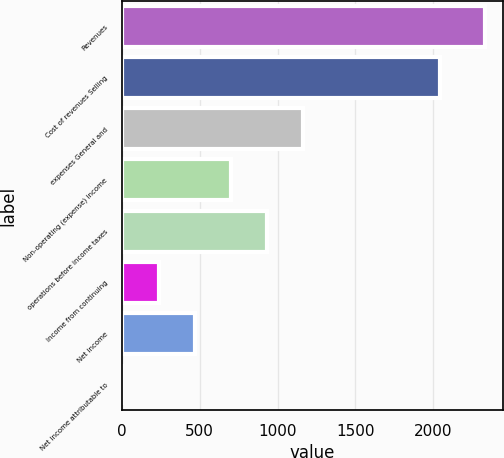<chart> <loc_0><loc_0><loc_500><loc_500><bar_chart><fcel>Revenues<fcel>Cost of revenues Selling<fcel>expenses General and<fcel>Non-operating (expense) income<fcel>operations before income taxes<fcel>Income from continuing<fcel>Net income<fcel>Net income attributable to<nl><fcel>2331<fcel>2045<fcel>1166.5<fcel>700.7<fcel>933.6<fcel>234.9<fcel>467.8<fcel>2<nl></chart> 